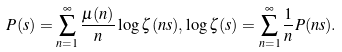Convert formula to latex. <formula><loc_0><loc_0><loc_500><loc_500>P ( s ) = \sum _ { n = 1 } ^ { \infty } \frac { \mu ( n ) } { n } \log \zeta ( n s ) , \log \zeta ( s ) = \sum _ { n = 1 } ^ { \infty } \frac { 1 } { n } P ( n s ) .</formula> 